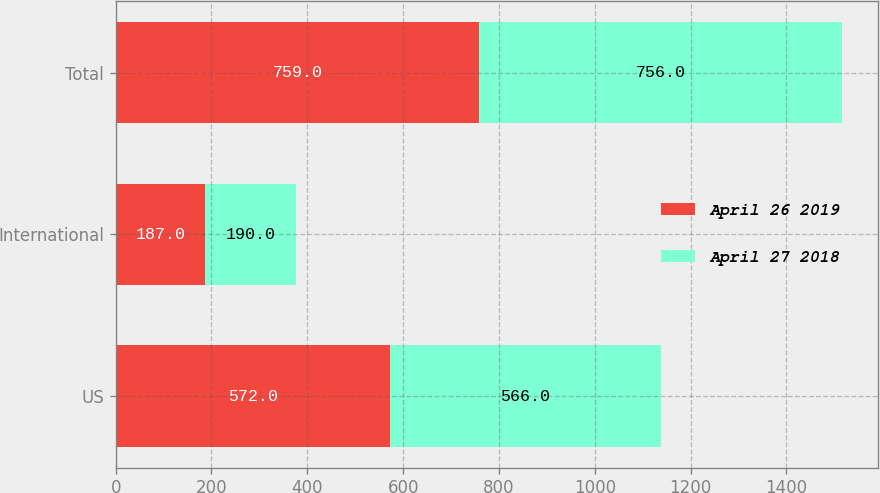Convert chart. <chart><loc_0><loc_0><loc_500><loc_500><stacked_bar_chart><ecel><fcel>US<fcel>International<fcel>Total<nl><fcel>April 26 2019<fcel>572<fcel>187<fcel>759<nl><fcel>April 27 2018<fcel>566<fcel>190<fcel>756<nl></chart> 